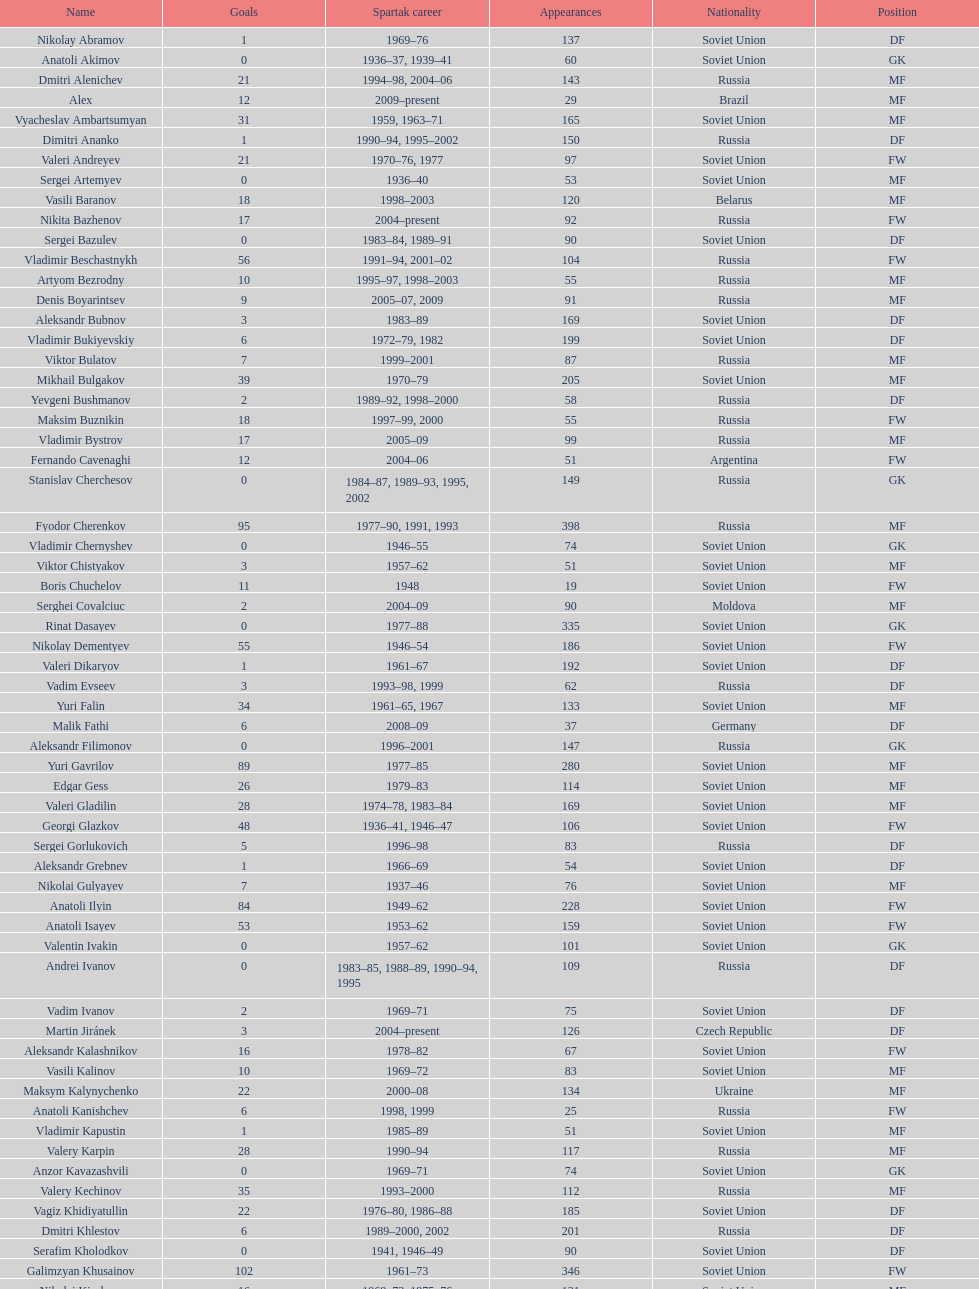Vladimir bukiyevskiy had how many appearances? 199. 